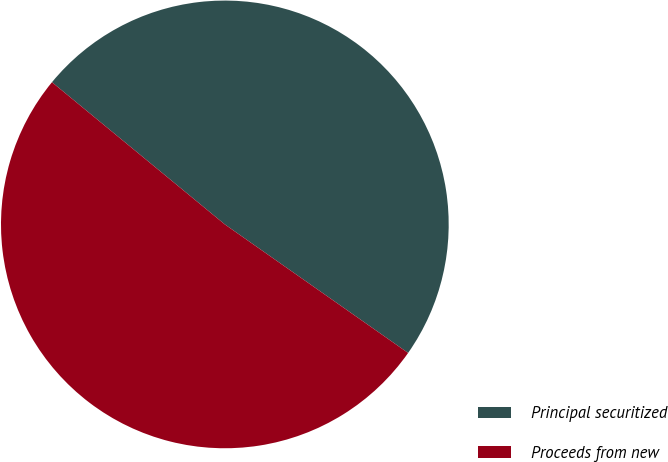Convert chart. <chart><loc_0><loc_0><loc_500><loc_500><pie_chart><fcel>Principal securitized<fcel>Proceeds from new<nl><fcel>48.78%<fcel>51.22%<nl></chart> 